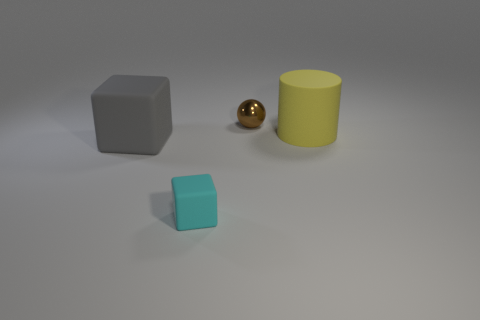Is there anything else that has the same material as the brown ball?
Make the answer very short. No. Is the shape of the cyan thing the same as the large thing that is on the right side of the gray rubber cube?
Your answer should be very brief. No. Do the matte thing that is left of the small rubber cube and the yellow rubber thing that is behind the cyan rubber cube have the same size?
Give a very brief answer. Yes. There is a big matte object that is on the left side of the rubber thing to the right of the small cyan thing; is there a tiny thing on the left side of it?
Offer a terse response. No. Are there fewer big yellow objects to the right of the small brown thing than gray rubber objects in front of the big gray block?
Your answer should be compact. No. There is a gray thing that is the same material as the yellow cylinder; what is its shape?
Keep it short and to the point. Cube. There is a cube in front of the matte block that is on the left side of the tiny thing in front of the small brown metallic ball; what is its size?
Keep it short and to the point. Small. Is the number of shiny balls greater than the number of small yellow shiny objects?
Keep it short and to the point. Yes. There is a matte object that is in front of the big cube; does it have the same color as the big thing that is to the right of the small metal object?
Your response must be concise. No. Do the large object to the left of the small brown metallic object and the block in front of the gray object have the same material?
Your answer should be compact. Yes. 